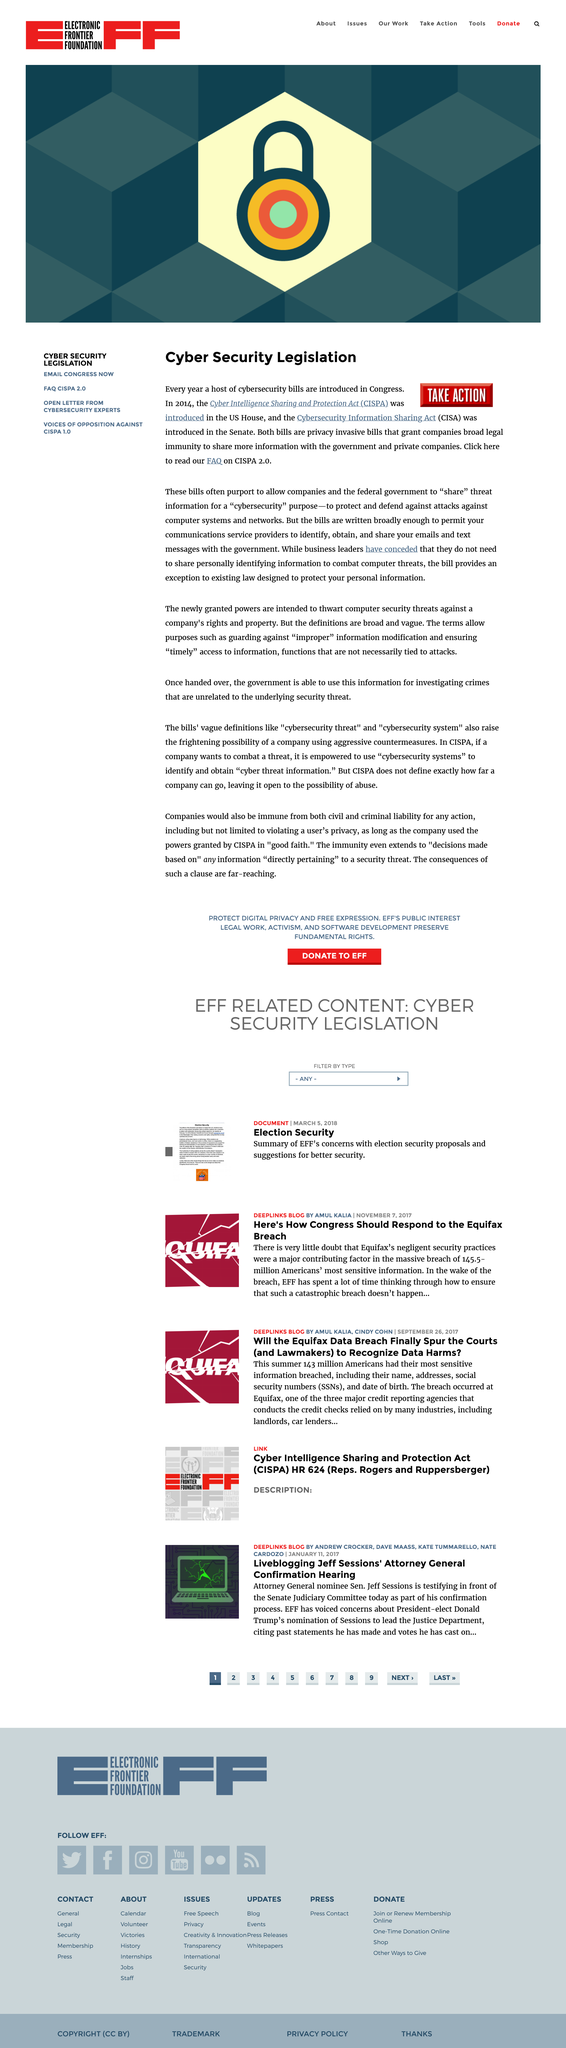Give some essential details in this illustration. In 2014, the Cyber Intelligence Sharing and Protection Act (CISA) was introduced in the Senate, marking a significant step forward in the fight against cyber threats. This landmark legislation aimed to promote the sharing of cyber threat information between government and private sector entities, as well as enhance cybersecurity awareness and protection. In 2014, the Cyber Intelligence Sharing and Protection Act (CISPA) was introduced in the US House of Representatives. Cyber security legislation is introduced into Congress, where it undergoes the legislative process before being signed into law. 